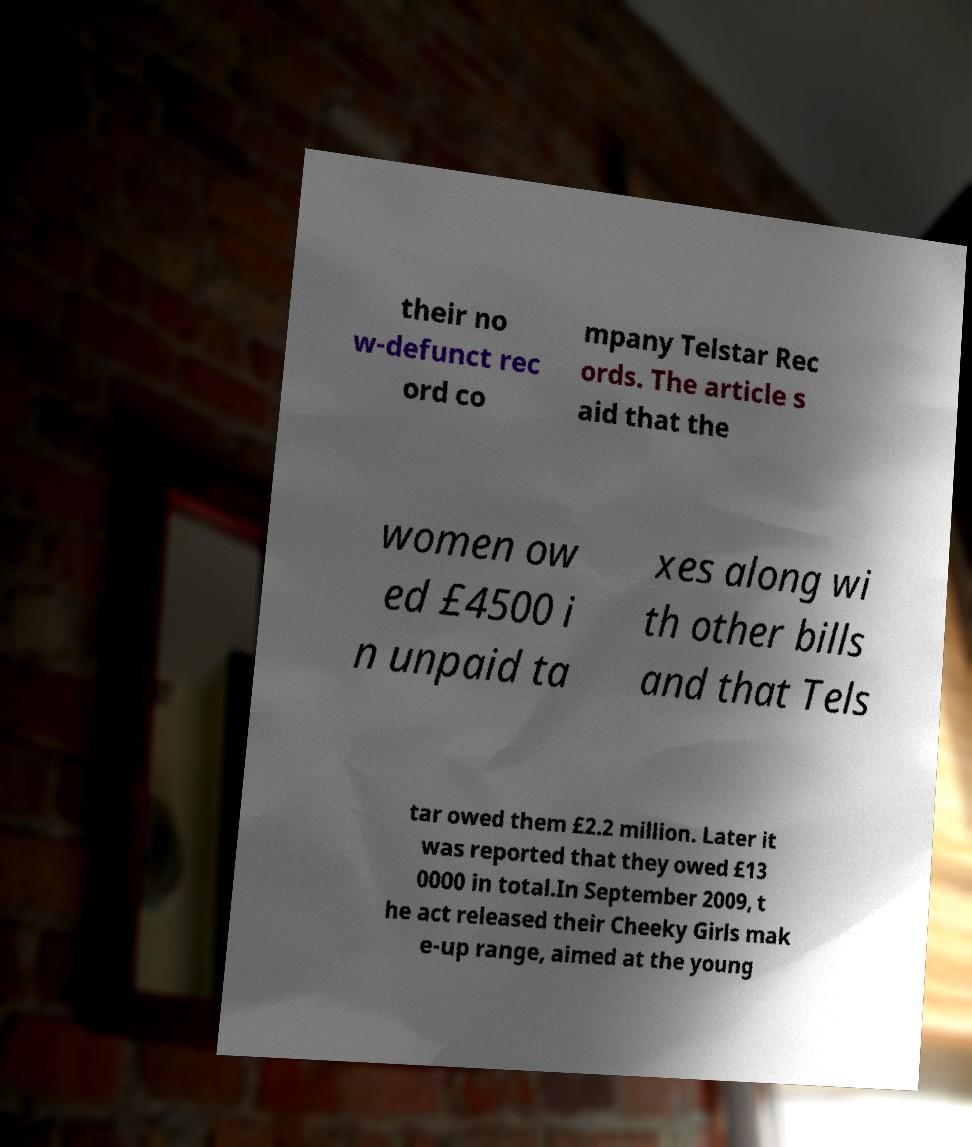For documentation purposes, I need the text within this image transcribed. Could you provide that? their no w-defunct rec ord co mpany Telstar Rec ords. The article s aid that the women ow ed £4500 i n unpaid ta xes along wi th other bills and that Tels tar owed them £2.2 million. Later it was reported that they owed £13 0000 in total.In September 2009, t he act released their Cheeky Girls mak e-up range, aimed at the young 